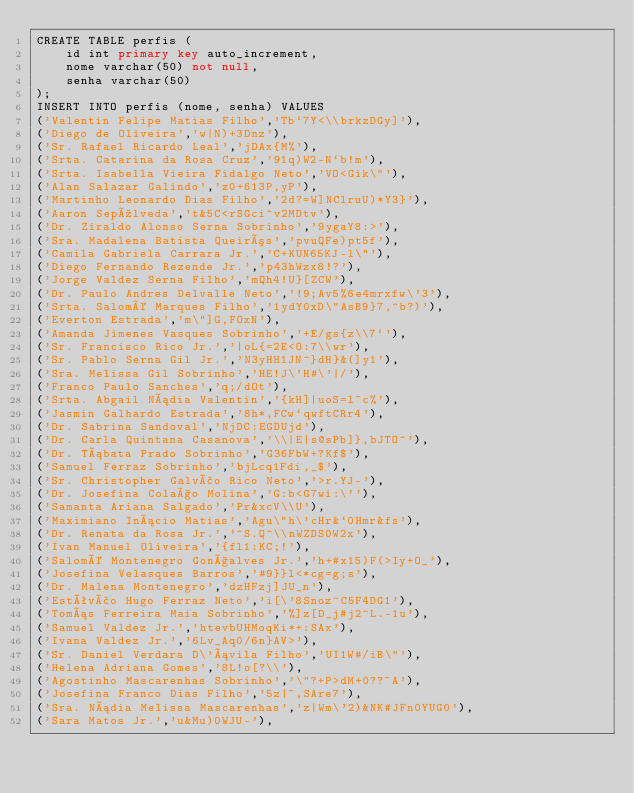<code> <loc_0><loc_0><loc_500><loc_500><_SQL_>CREATE TABLE perfis (
    id int primary key auto_increment,
    nome varchar(50) not null,
    senha varchar(50)
);
INSERT INTO perfis (nome, senha) VALUES 
('Valentin Felipe Matias Filho','Tb`7Y<\\brkzDGy]'),
('Diego de Oliveira','w|N)+3Dnz'),
('Sr. Rafael Ricardo Leal','jDAx{M%'),
('Srta. Catarina da Rosa Cruz','91q)W2-N`b!m'),
('Srta. Isabella Vieira Fidalgo Neto','VO<Gik\"'),
('Alan Salazar Galindo','z0+613P,yP'),
('Martinho Leonardo Dias Filho','2d?=W]NClruU)*Y3}'),
('Aaron Sepúlveda','t&5C<rSGci^v2MDtv'),
('Dr. Ziraldo Alonso Serna Sobrinho','9ygaY8:>'),
('Sra. Madalena Batista Queirós','pvuQFe)pt5f'),
('Camila Gabriela Carrara Jr.','C+KUN65KJ-l\"'),
('Diego Fernando Rezende Jr.','p43hWzx8!?'),
('Jorge Valdez Serna Filho','mQh4!U}[ZCW'),
('Dr. Paulo Andres Delvalle Neto','!9;Av5%6e4mrxfw\'3'),
('Srta. Salomé Marques Filho','1ydY0xD\"AsB9}7,^b?)'),
('Everton Estrada','m\"]G,FOxN'),
('Amanda Jimenes Vasques Sobrinho','+E/gs{z\\7`'),
('Sr. Francisco Rico Jr.','|oL{=2E<O:7\\wr'),
('Sr. Pablo Serna Gil Jr.','N3yHH1JN^}dH}&(]y1'),
('Sra. Melissa Gil Sobrinho','HE!J\'H#\'|/'),
('Franco Paulo Sanches','q;/dOt'),
('Srta. Abgail Nádia Valentin','{kH]|uoS=l~c%'),
('Jasmin Galhardo Estrada','8h*,FCw`qwftCRr4'),
('Dr. Sabrina Sandoval','NjDC:EGDUjd'),
('Dr. Carla Quintana Casanova','\\|E|s@sPb]},bJTO^'),
('Dr. Tábata Prado Sobrinho','G36FbW+?Kf$'),
('Samuel Ferraz Sobrinho','bjLcq1Fdi,_$'),
('Sr. Christopher Galvão Rico Neto','>r.YJ-'),
('Dr. Josefina Colaço Molina','G:b<G7wi:\''),
('Samanta Ariana Salgado','Pr&xcV\\U'),
('Maximiano Inácio Matias','Agu\"h\'cHr&`0Hmr&fs'),
('Dr. Renata da Rosa Jr.','^S.Q^\\nWZDS0W2x'),
('Ivan Manuel Oliveira','{fl1:KC;!'),
('Salomé Montenegro Gonçalves Jr.','h+#x15)F(>Iy+O_'),
('Josefina Velasques Barros','#9}}l<*cg=g;s'),
('Dr. Malena Montenegro','dzHFzj]JU_n'),
('Estêvão Hugo Ferraz Neto','i[\'8Snoz^C5F4DG1'),
('Tomás Ferreira Maia Sobrinho','%]z[D_j#j2^L.-1u'),
('Samuel Valdez Jr.','htevbUHMoqKi*+:SAx'),
('Ivana Valdez Jr.','6Lv_Aq0/6n}AV>'),
('Sr. Daniel Verdara D\'ávila Filho','UI1W#/iB\"'),
('Helena Adriana Gomes','8L!o[?\\'),
('Agostinho Mascarenhas Sobrinho','\"?+P>dM+0??~A'),
('Josefina Franco Dias Filho','5z|~,SAre7'),
('Sra. Nádia Melissa Mascarenhas','z|Wm\'2)&NK#JFn0YUG0'),
('Sara Matos Jr.','u&Mu)0WJU-'),</code> 